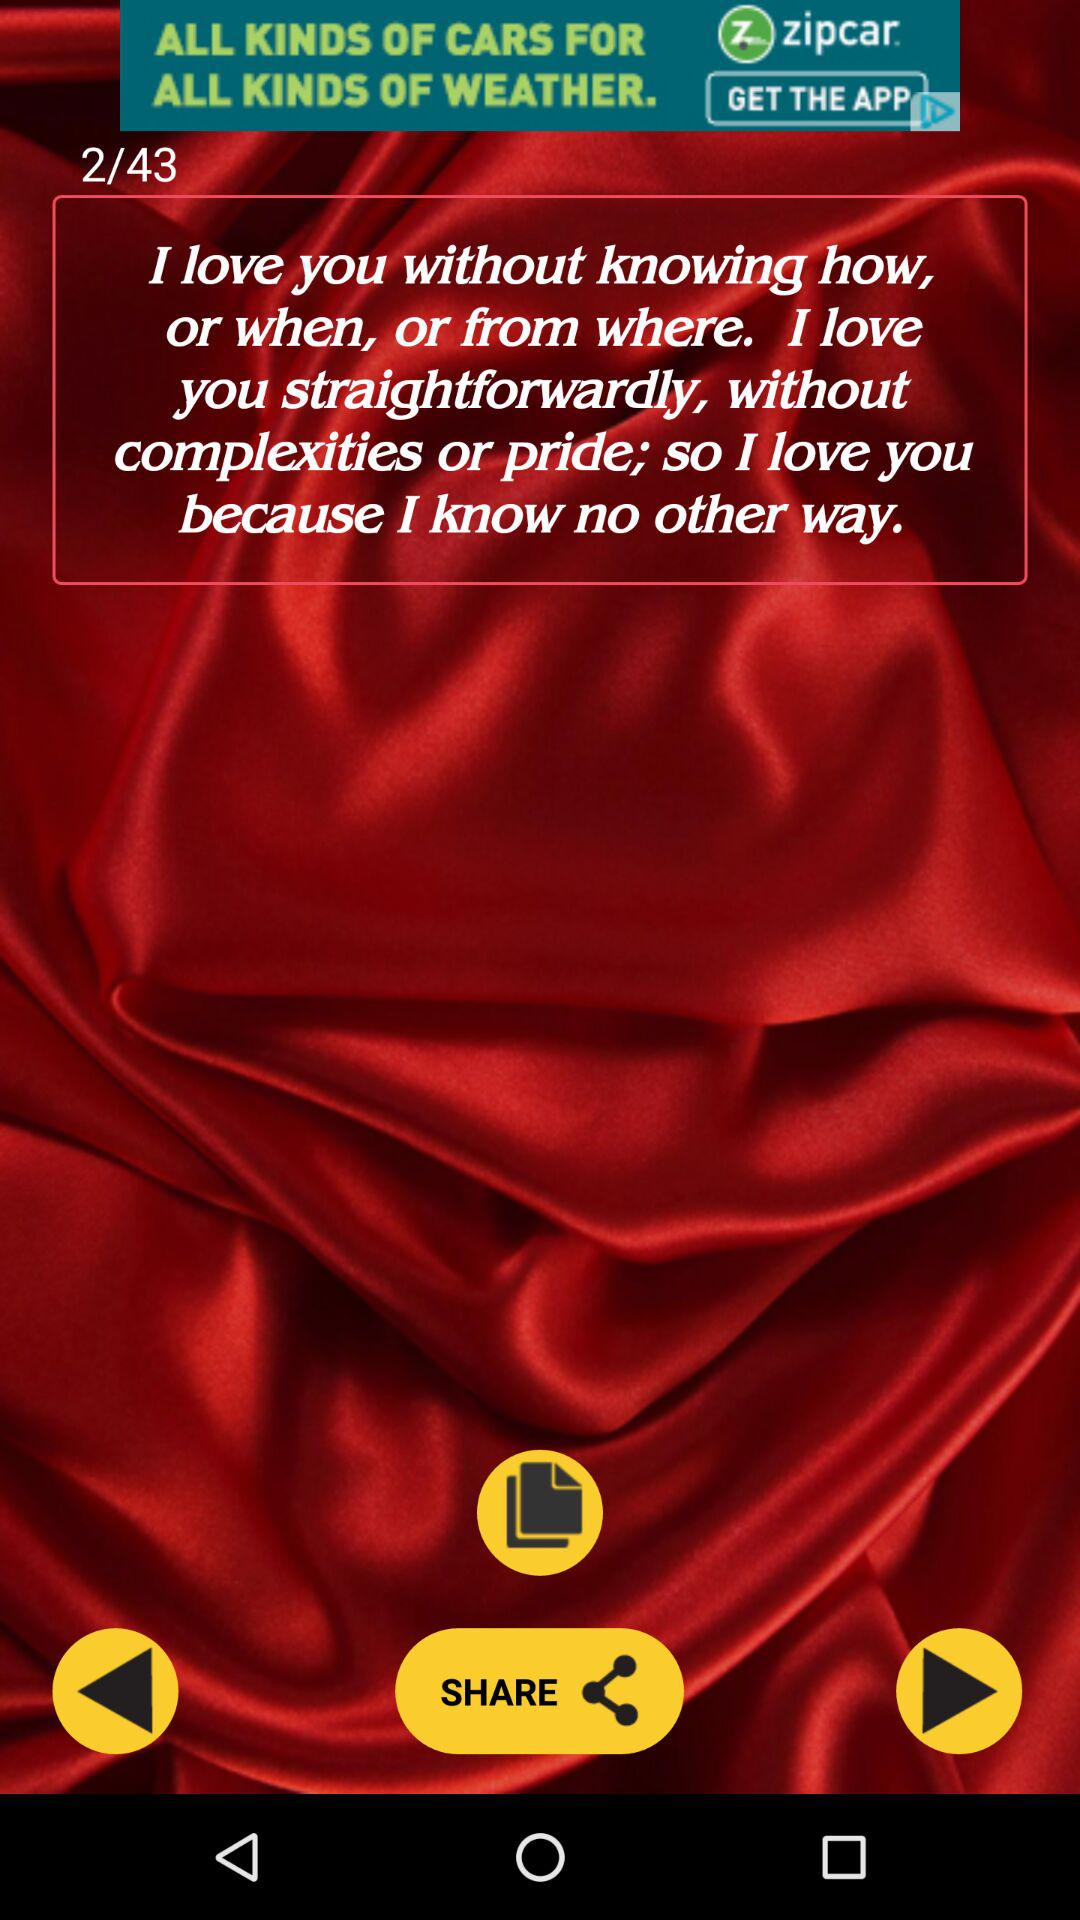Who wrote the message about love?
When the provided information is insufficient, respond with <no answer>. <no answer> 